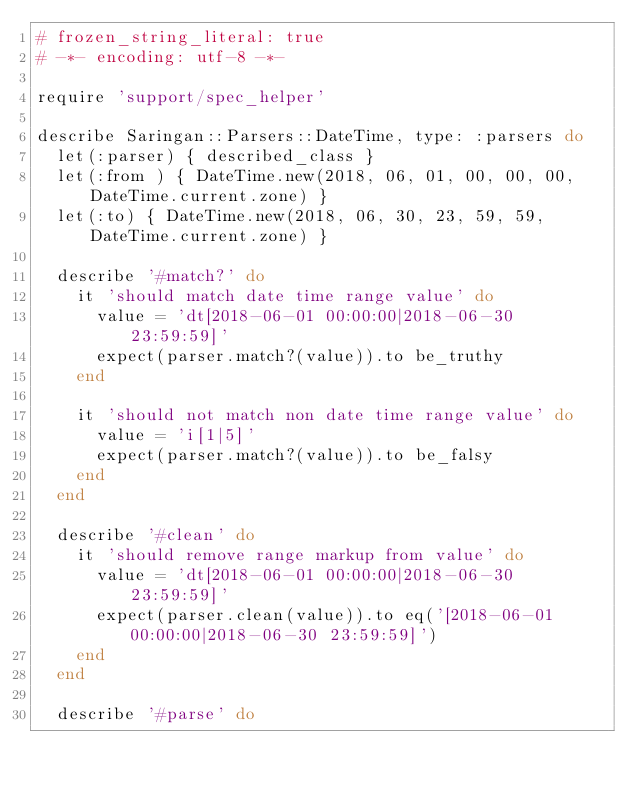<code> <loc_0><loc_0><loc_500><loc_500><_Ruby_># frozen_string_literal: true
# -*- encoding: utf-8 -*-

require 'support/spec_helper'

describe Saringan::Parsers::DateTime, type: :parsers do
  let(:parser) { described_class }
  let(:from ) { DateTime.new(2018, 06, 01, 00, 00, 00, DateTime.current.zone) }
  let(:to) { DateTime.new(2018, 06, 30, 23, 59, 59, DateTime.current.zone) }

  describe '#match?' do
    it 'should match date time range value' do
      value = 'dt[2018-06-01 00:00:00|2018-06-30 23:59:59]'
      expect(parser.match?(value)).to be_truthy
    end

    it 'should not match non date time range value' do
      value = 'i[1|5]'
      expect(parser.match?(value)).to be_falsy
    end
  end

  describe '#clean' do
    it 'should remove range markup from value' do
      value = 'dt[2018-06-01 00:00:00|2018-06-30 23:59:59]'
      expect(parser.clean(value)).to eq('[2018-06-01 00:00:00|2018-06-30 23:59:59]')
    end
  end

  describe '#parse' do</code> 